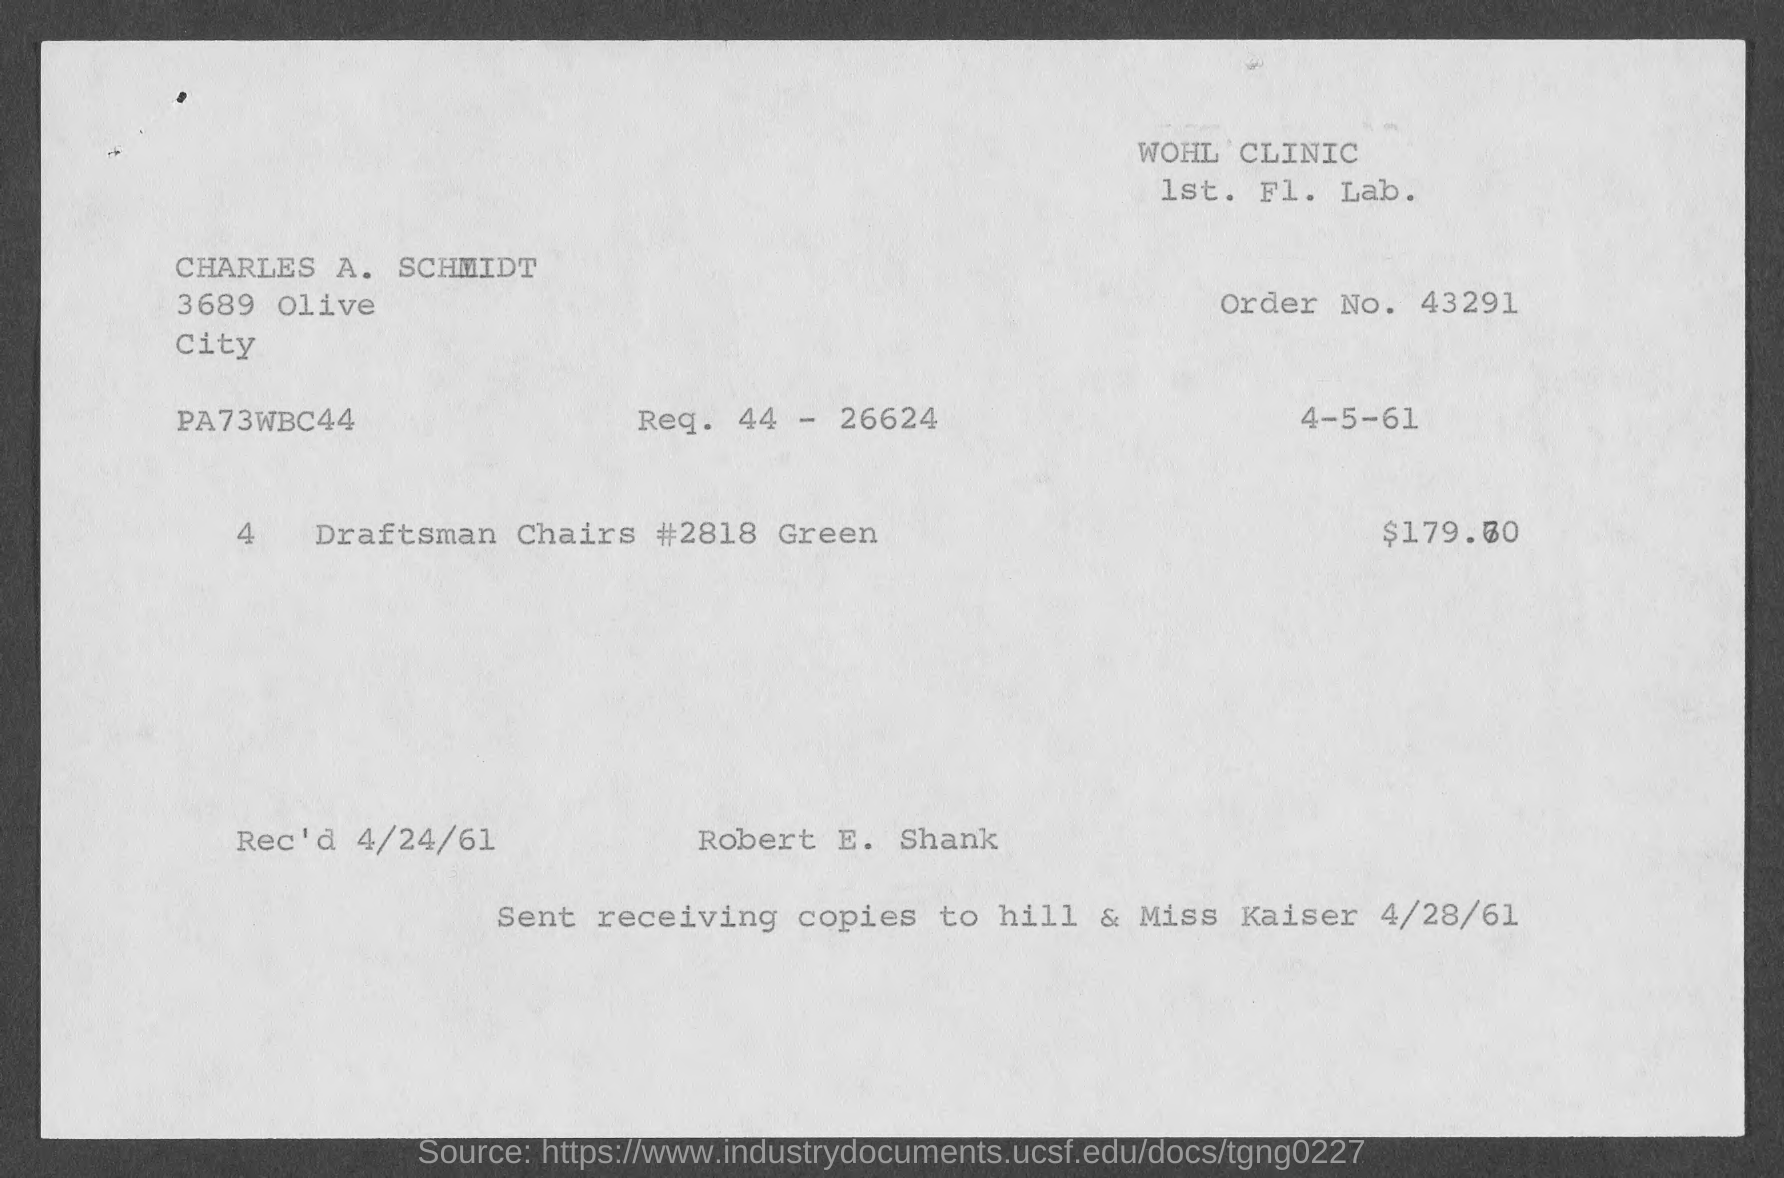Draw attention to some important aspects in this diagram. The recipient for the copies should be sent to "Hill & Miss Kaiser. The request is for a result of 44 minus 26624. The document was received on April 24th, 1961. The order number is 43291... 